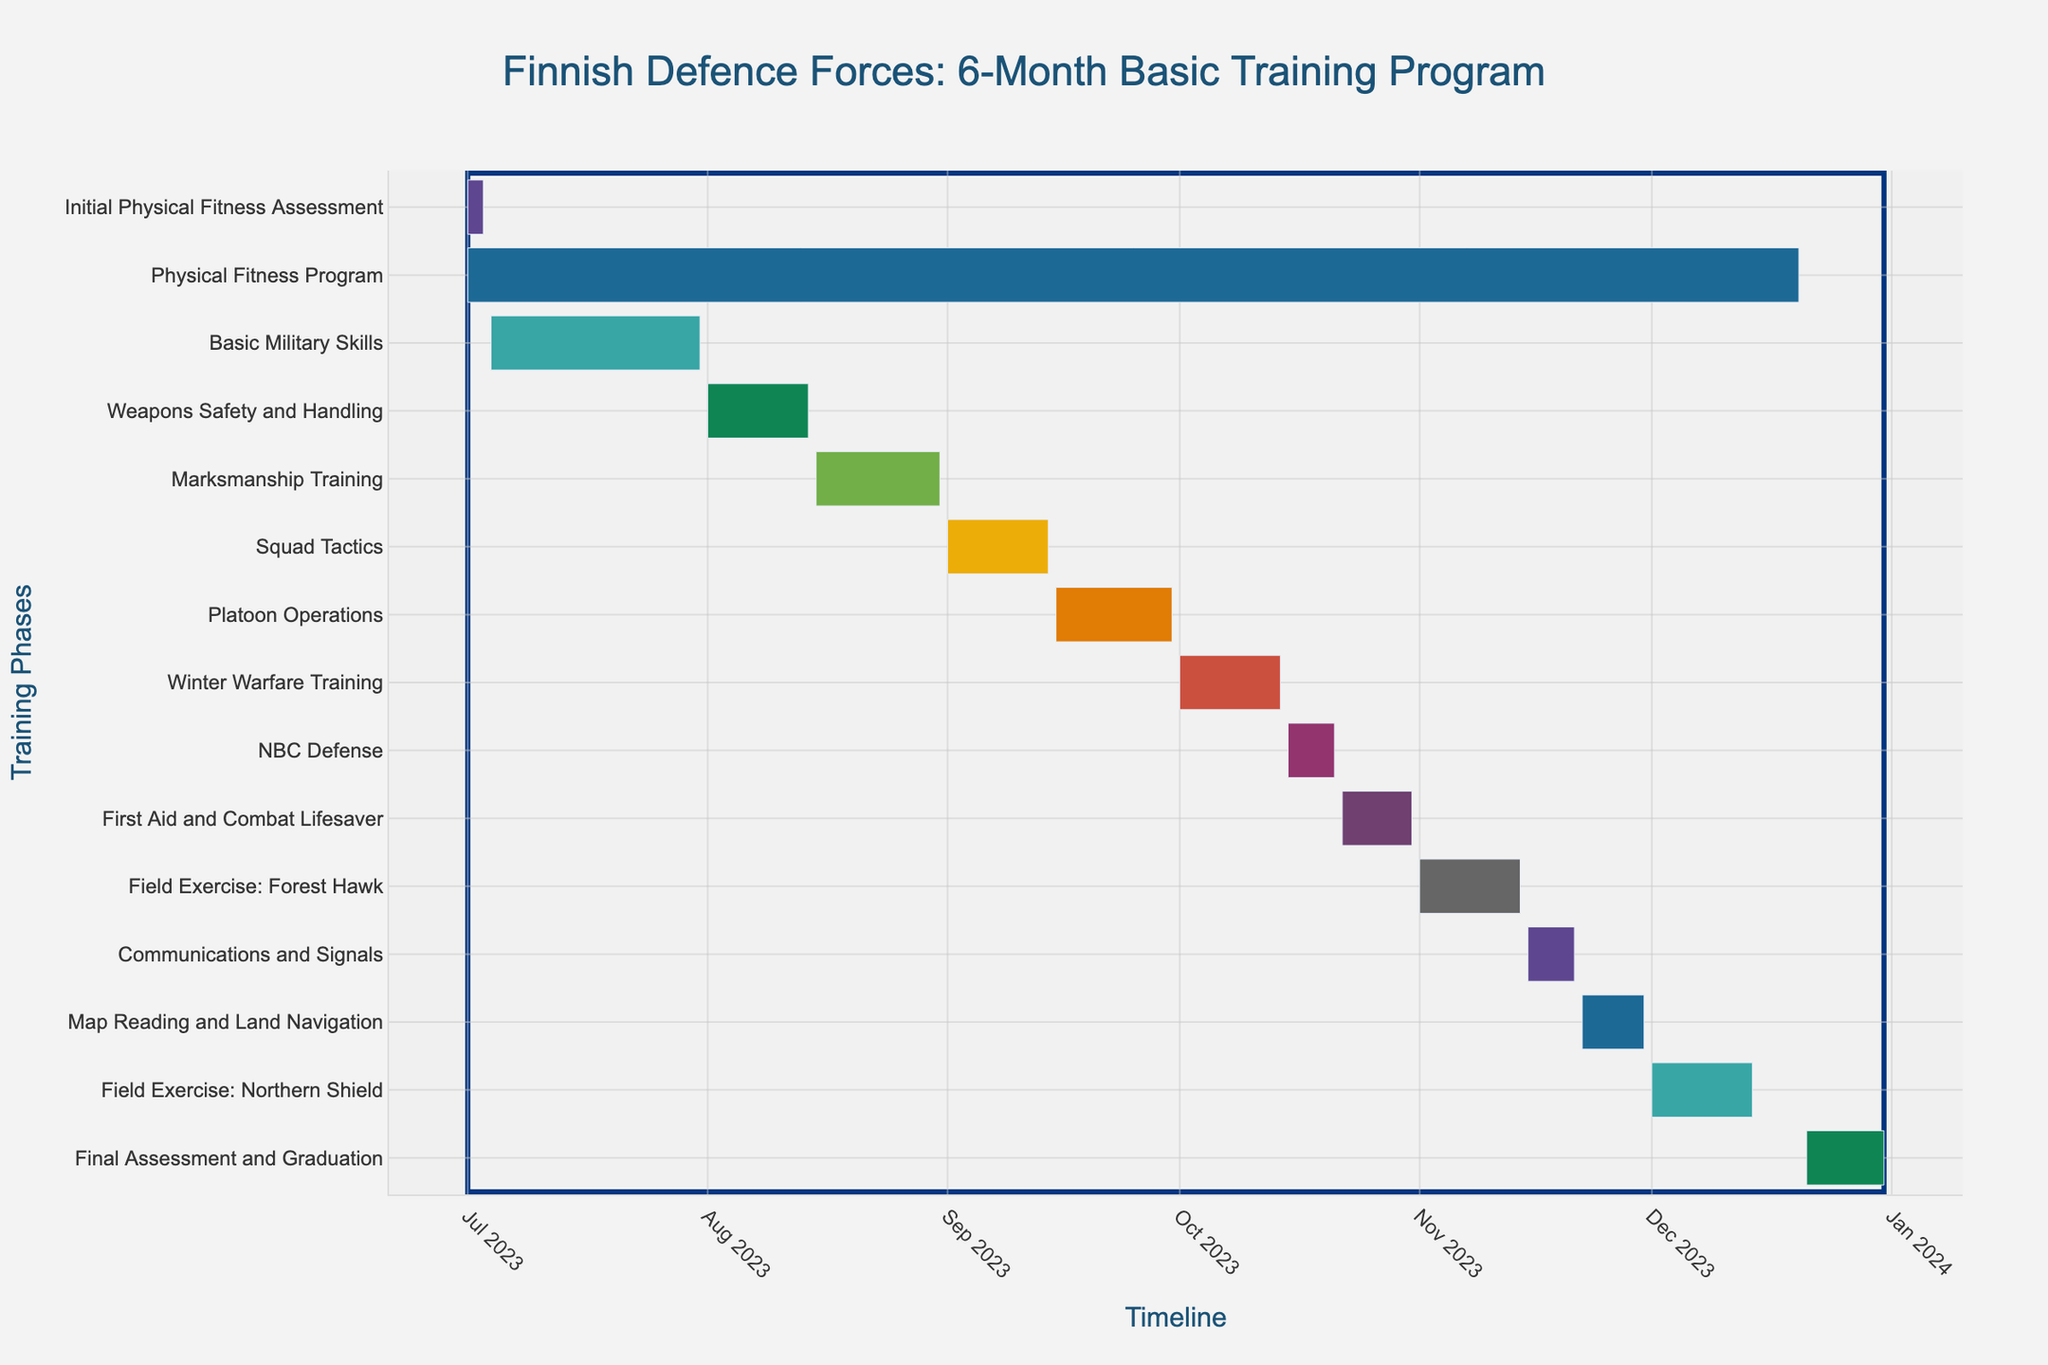How long is the entire training program? Look at the initial and final tasks on the Gantt chart. The program starts on 2023-07-01 and ends on 2023-12-31, indicating it is a 6-month program.
Answer: 6 months How long does the Marksmanship Training phase last? Refer to the Gantt chart for the Marksmanship Training phase. It starts on 2023-08-15 and ends on 2023-08-31, spanning 17 days.
Answer: 17 days Which phase starts immediately after the Basic Military Skills? Check the sequence of tasks. The Basic Military Skills end on 2023-07-31, and the subsequent phase, Weapons Safety and Handling, starts on 2023-08-01.
Answer: Weapons Safety and Handling Which phase is longer: Winter Warfare Training or NBC Defense? Compare the durations of Winter Warfare Training (2023-10-01 to 2023-10-14, 14 days) and NBC Defense (2023-10-15 to 2023-10-21, 7 days). Winter Warfare Training is longer.
Answer: Winter Warfare Training Are there any phases that overlap with the Physical Fitness Program? Identify phases occurring between 2023-07-01 and 2023-12-20. All individual tasks from the Initial Physical Fitness Assessment to Final Assessment and Graduation overlap with the Physical Fitness Program.
Answer: Yes Which phase has the shortest duration? Review the chart for the shortest span between start and end dates. NBC Defense lasts the shortest from 2023-10-15 to 2023-10-21 (7 days).
Answer: NBC Defense How many field exercises are scheduled in the program? Count the tasks explicitly labeled as "Field Exercise." There are two: Forest Hawk and Northern Shield.
Answer: 2 What is the total duration of all field exercises combined? The durations of Forest Hawk (2023-11-01 to 2023-11-14, 14 days) and Northern Shield (2023-12-01 to 2023-12-14, 14 days) sum up to 28 days.
Answer: 28 days What is the end date of the Final Assessment and Graduation phase? Refer to the Gantt chart to locate the end date of the Final Assessment and Graduation phase. It ends on 2023-12-31.
Answer: 2023-12-31 Which phase takes place entirely in September? Identify phases starting and ending in September. Platoon Operations takes place entirely in September (2023-09-15 to 2023-09-30).
Answer: Platoon Operations 